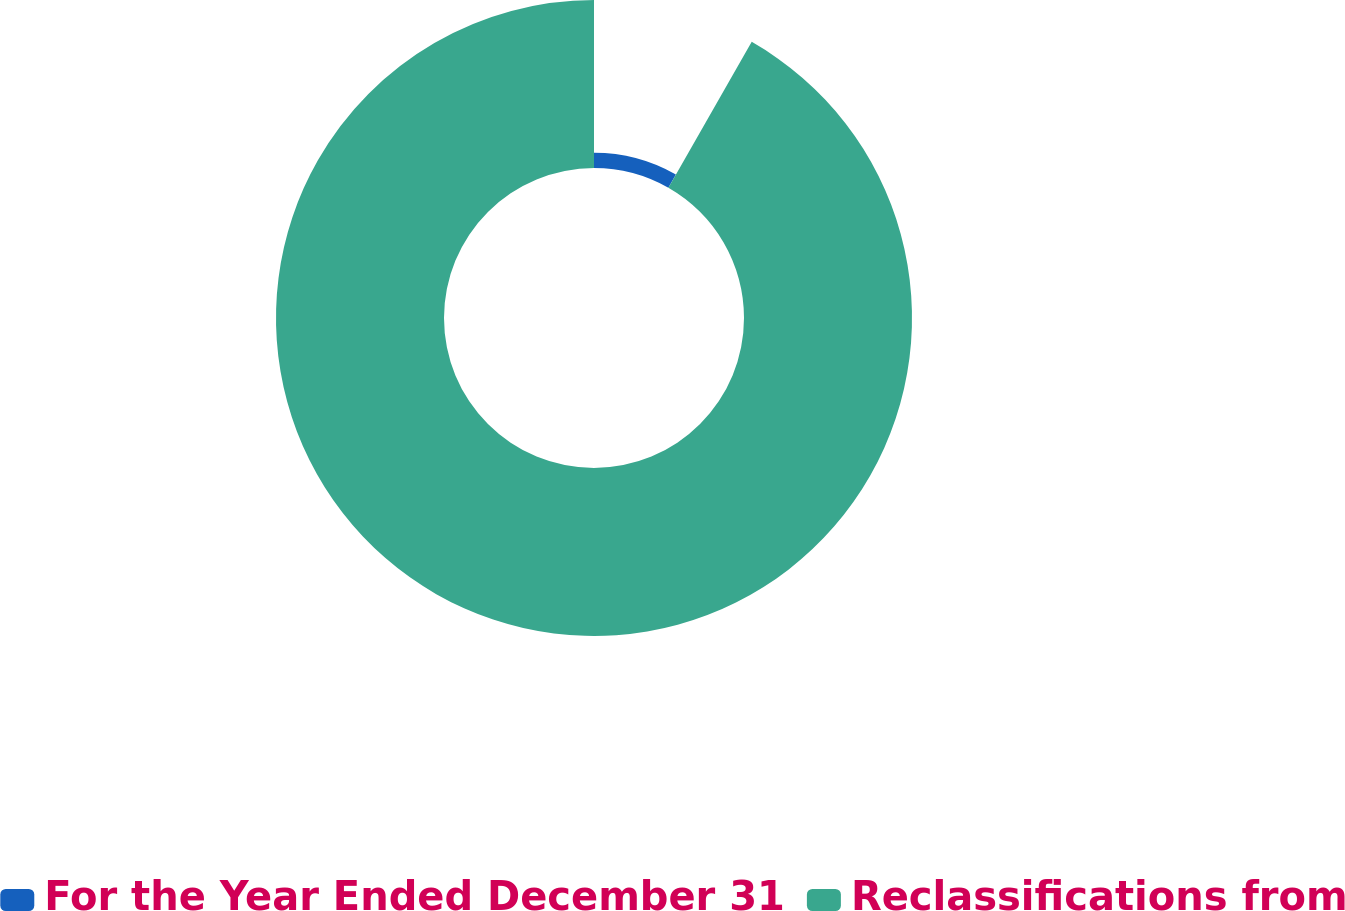Convert chart. <chart><loc_0><loc_0><loc_500><loc_500><pie_chart><fcel>For the Year Ended December 31<fcel>Reclassifications from<nl><fcel>8.26%<fcel>91.74%<nl></chart> 